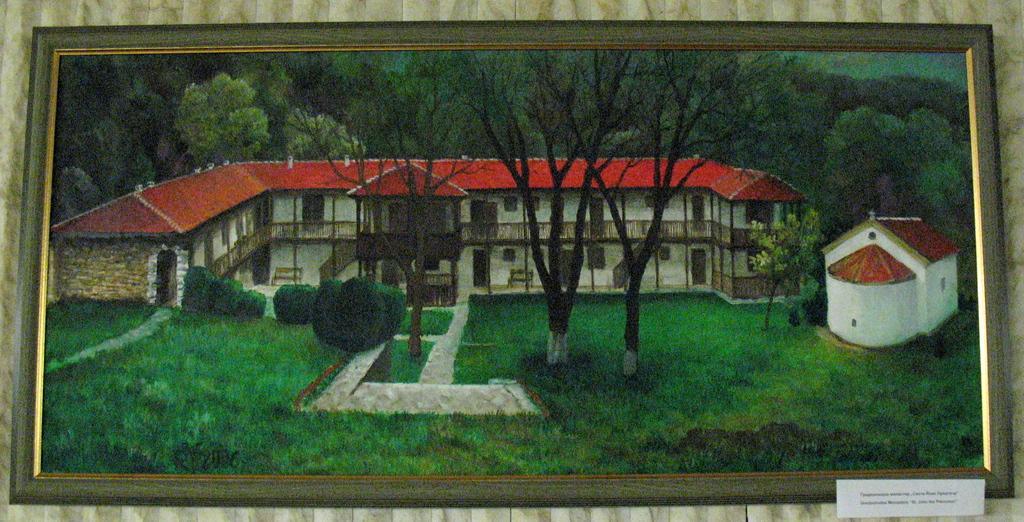In one or two sentences, can you explain what this image depicts? Picture is on the wall. In-front of this picture there is an information card. In this picture we can see trees, plants, horses and grass. 